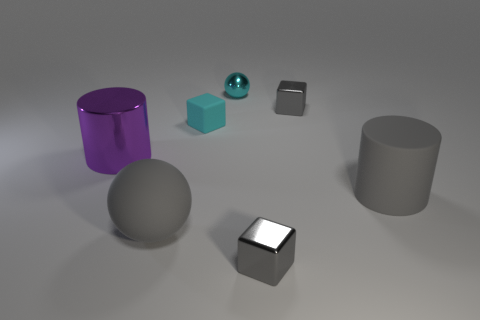There is a small matte cube; does it have the same color as the big rubber thing that is on the right side of the large gray ball?
Your response must be concise. No. The cylinder on the right side of the tiny gray block behind the metallic cube in front of the large gray cylinder is made of what material?
Offer a very short reply. Rubber. Is the material of the purple object the same as the block that is on the left side of the cyan metal thing?
Give a very brief answer. No. There is another thing that is the same shape as the large purple metallic thing; what is its material?
Provide a short and direct response. Rubber. Are there any other things that have the same material as the large sphere?
Your response must be concise. Yes. Are there more blocks that are to the left of the big purple cylinder than shiny cylinders in front of the big gray cylinder?
Your response must be concise. No. What is the shape of the large object that is made of the same material as the small cyan sphere?
Keep it short and to the point. Cylinder. How many other objects are the same shape as the purple shiny thing?
Ensure brevity in your answer.  1. There is a small shiny object that is in front of the matte cube; what is its shape?
Your response must be concise. Cube. The tiny rubber thing has what color?
Provide a succinct answer. Cyan. 